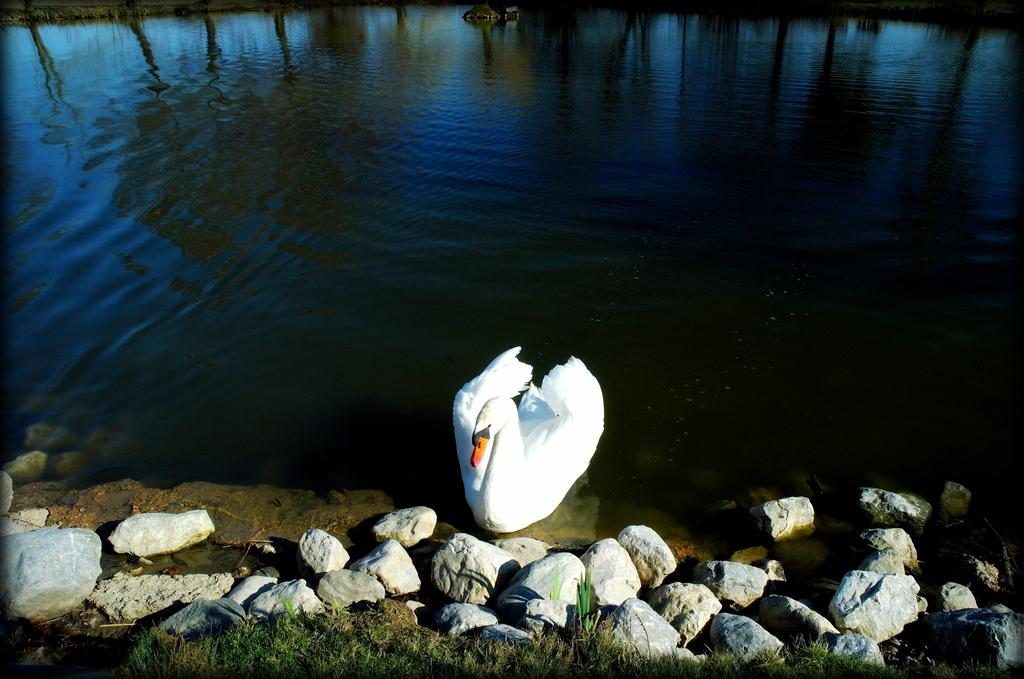What type of animal is in the water in the image? There is a bird in the water in the image. What other elements can be seen in the image besides the bird? There are stones, grass, trees, and a house visible in the image. Can you describe the natural environment in the image? The image features grass, trees, and a body of water with a bird in it. What might be the time of day in the image? The image may have been taken during night, as suggested by the absence of sunlight. What type of education does the bird in the image have? There is no information about the bird's education in the image. How does the bird in the image prepare for winter? There is no indication of winter in the image, and the bird's behavior or preparations cannot be determined from the image alone. 